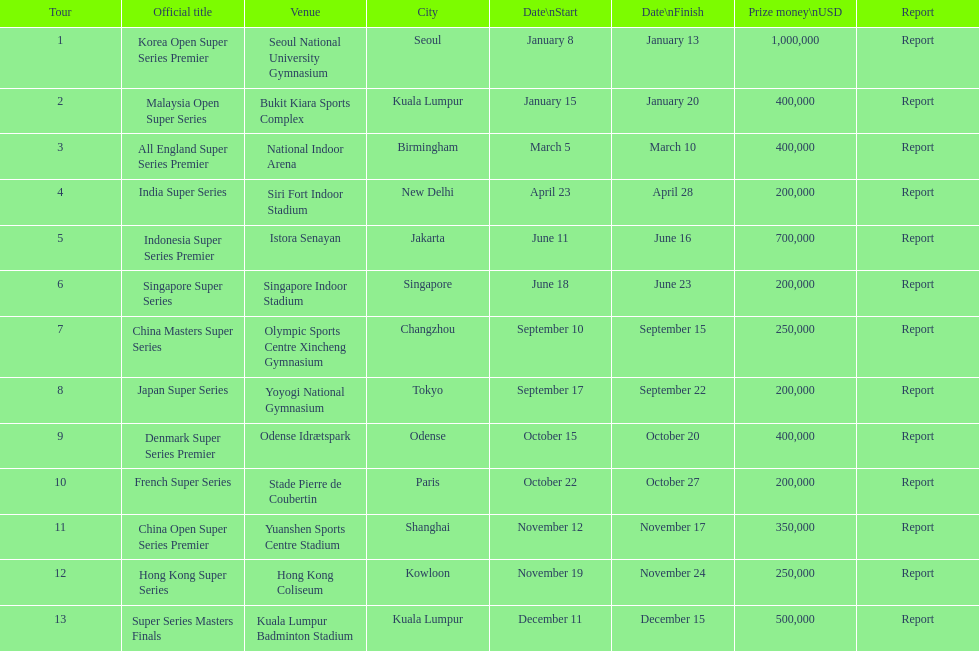How many days is the japan super series held for? 5. 